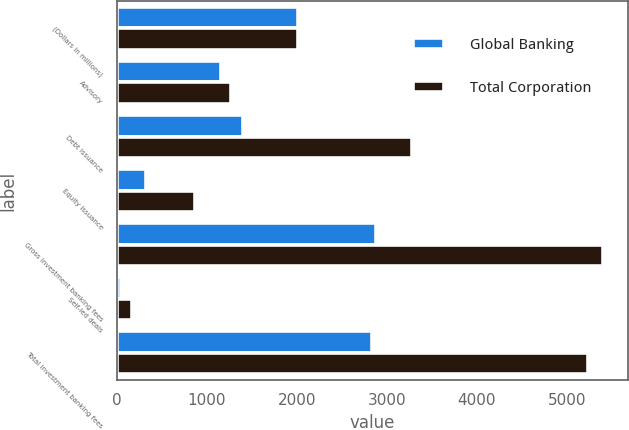<chart> <loc_0><loc_0><loc_500><loc_500><stacked_bar_chart><ecel><fcel>(Dollars in millions)<fcel>Advisory<fcel>Debt issuance<fcel>Equity issuance<fcel>Gross investment banking fees<fcel>Self-led deals<fcel>Total investment banking fees<nl><fcel>Global Banking<fcel>2016<fcel>1156<fcel>1407<fcel>321<fcel>2884<fcel>49<fcel>2835<nl><fcel>Total Corporation<fcel>2016<fcel>1269<fcel>3276<fcel>864<fcel>5409<fcel>168<fcel>5241<nl></chart> 